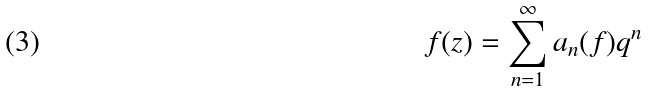Convert formula to latex. <formula><loc_0><loc_0><loc_500><loc_500>f ( z ) = \sum _ { n = 1 } ^ { \infty } a _ { n } ( f ) q ^ { n }</formula> 